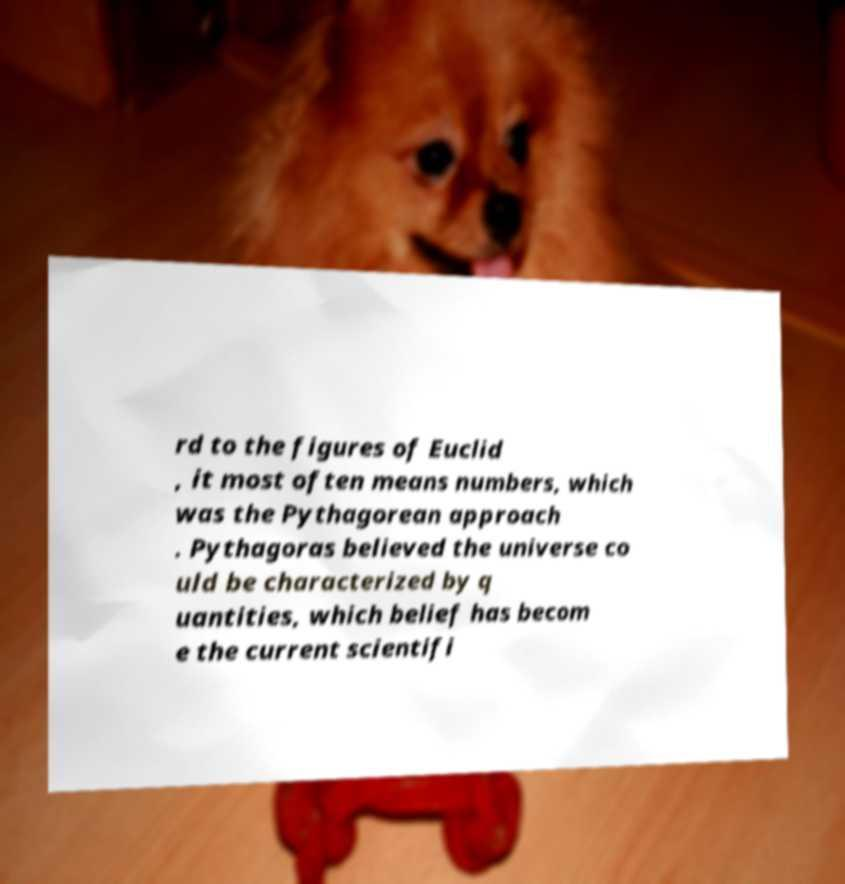Can you accurately transcribe the text from the provided image for me? rd to the figures of Euclid , it most often means numbers, which was the Pythagorean approach . Pythagoras believed the universe co uld be characterized by q uantities, which belief has becom e the current scientifi 